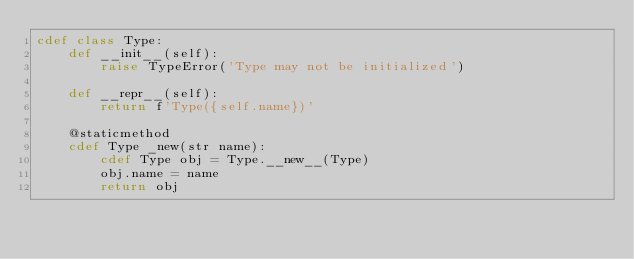<code> <loc_0><loc_0><loc_500><loc_500><_Cython_>cdef class Type:
    def __init__(self):
        raise TypeError('Type may not be initialized')

    def __repr__(self):
        return f'Type({self.name})'

    @staticmethod
    cdef Type _new(str name):
        cdef Type obj = Type.__new__(Type)
        obj.name = name
        return obj
</code> 